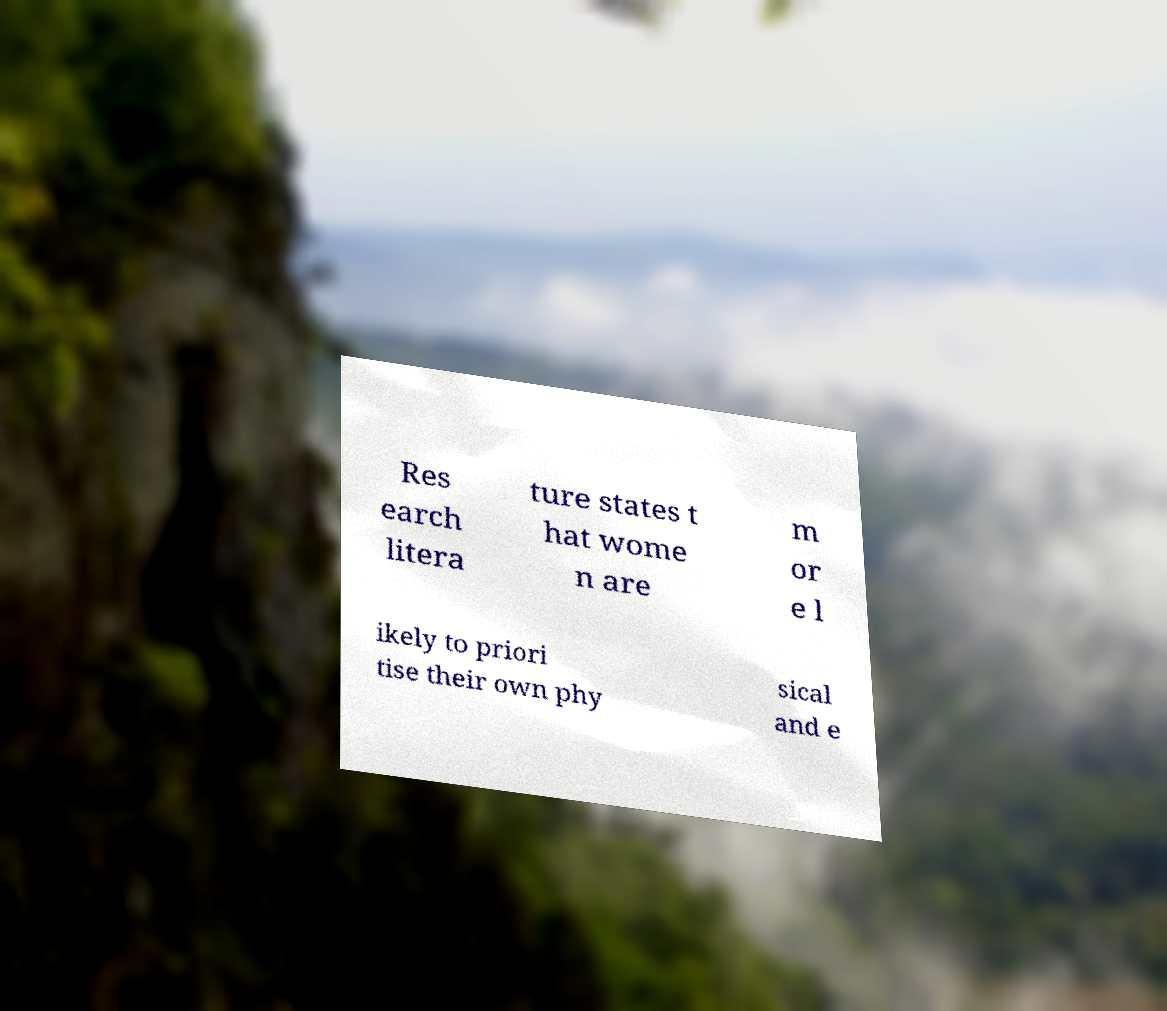Could you assist in decoding the text presented in this image and type it out clearly? Res earch litera ture states t hat wome n are m or e l ikely to priori tise their own phy sical and e 